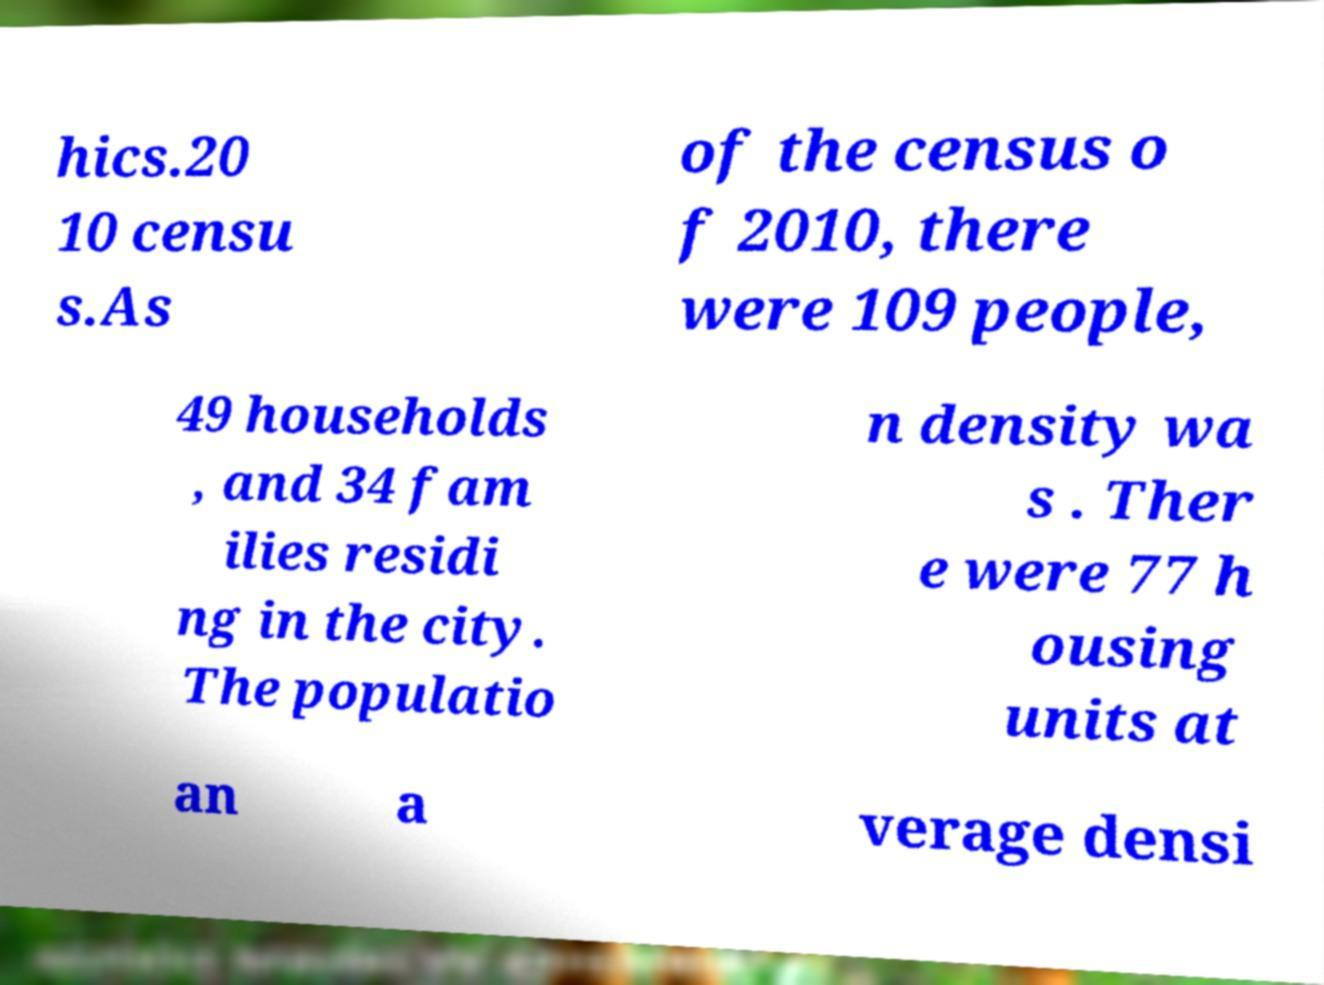For documentation purposes, I need the text within this image transcribed. Could you provide that? hics.20 10 censu s.As of the census o f 2010, there were 109 people, 49 households , and 34 fam ilies residi ng in the city. The populatio n density wa s . Ther e were 77 h ousing units at an a verage densi 